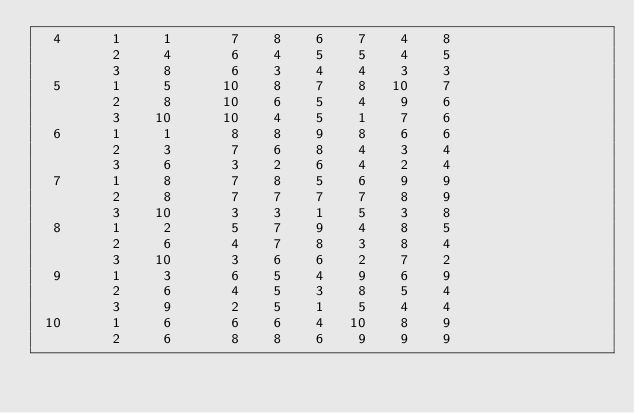<code> <loc_0><loc_0><loc_500><loc_500><_ObjectiveC_>  4      1     1       7    8    6    7    4    8
         2     4       6    4    5    5    4    5
         3     8       6    3    4    4    3    3
  5      1     5      10    8    7    8   10    7
         2     8      10    6    5    4    9    6
         3    10      10    4    5    1    7    6
  6      1     1       8    8    9    8    6    6
         2     3       7    6    8    4    3    4
         3     6       3    2    6    4    2    4
  7      1     8       7    8    5    6    9    9
         2     8       7    7    7    7    8    9
         3    10       3    3    1    5    3    8
  8      1     2       5    7    9    4    8    5
         2     6       4    7    8    3    8    4
         3    10       3    6    6    2    7    2
  9      1     3       6    5    4    9    6    9
         2     6       4    5    3    8    5    4
         3     9       2    5    1    5    4    4
 10      1     6       6    6    4   10    8    9
         2     6       8    8    6    9    9    9</code> 